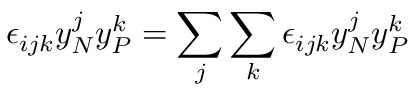Convert formula to latex. <formula><loc_0><loc_0><loc_500><loc_500>\epsilon _ { i j k } y _ { N } ^ { j } y _ { P } ^ { k } = \sum _ { j } \sum _ { k } \epsilon _ { i j k } y _ { N } ^ { j } y _ { P } ^ { k }</formula> 